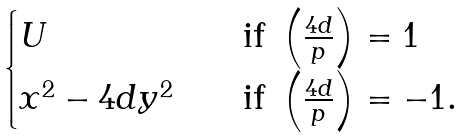Convert formula to latex. <formula><loc_0><loc_0><loc_500><loc_500>\begin{cases} U \quad & \text {if } \left ( \frac { 4 d } { p } \right ) = 1 \\ x ^ { 2 } - 4 d y ^ { 2 } \quad & \text {if } \left ( \frac { 4 d } { p } \right ) = - 1 . \end{cases}</formula> 